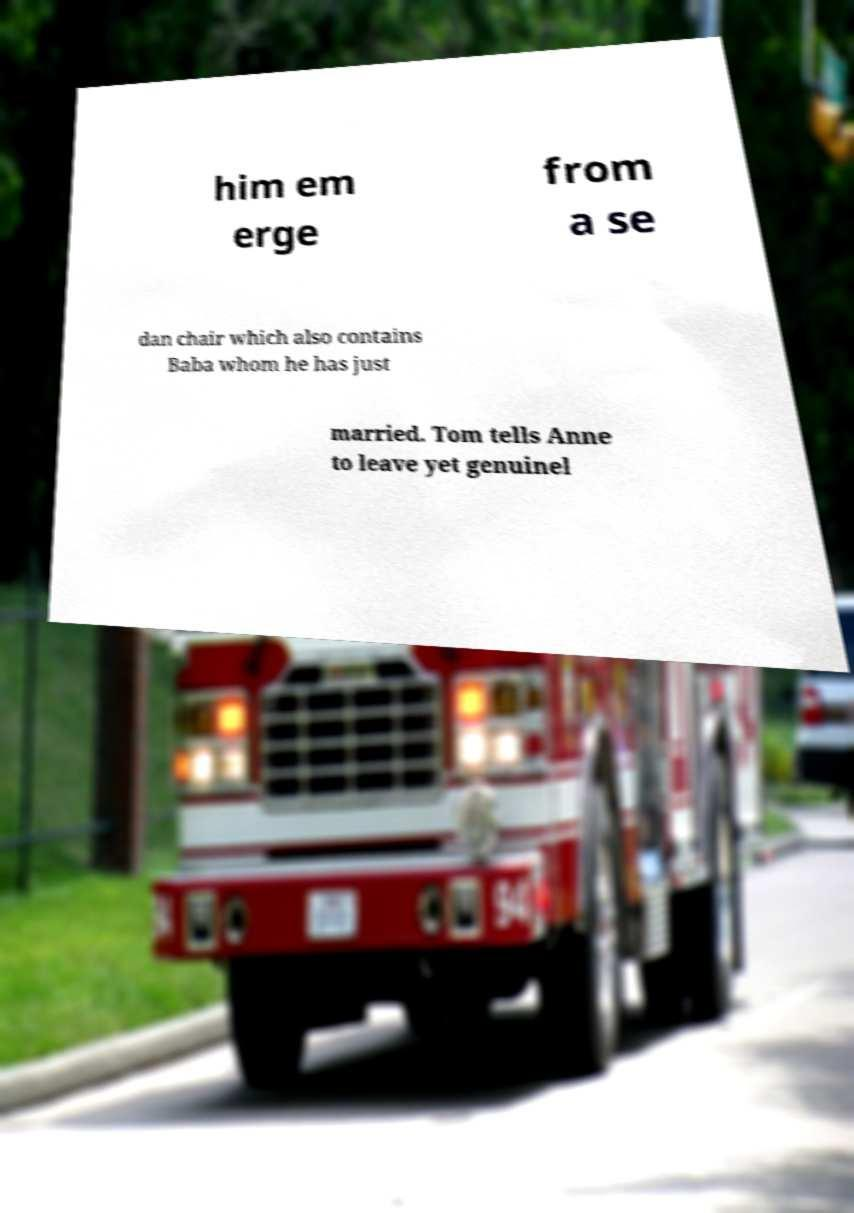For documentation purposes, I need the text within this image transcribed. Could you provide that? him em erge from a se dan chair which also contains Baba whom he has just married. Tom tells Anne to leave yet genuinel 